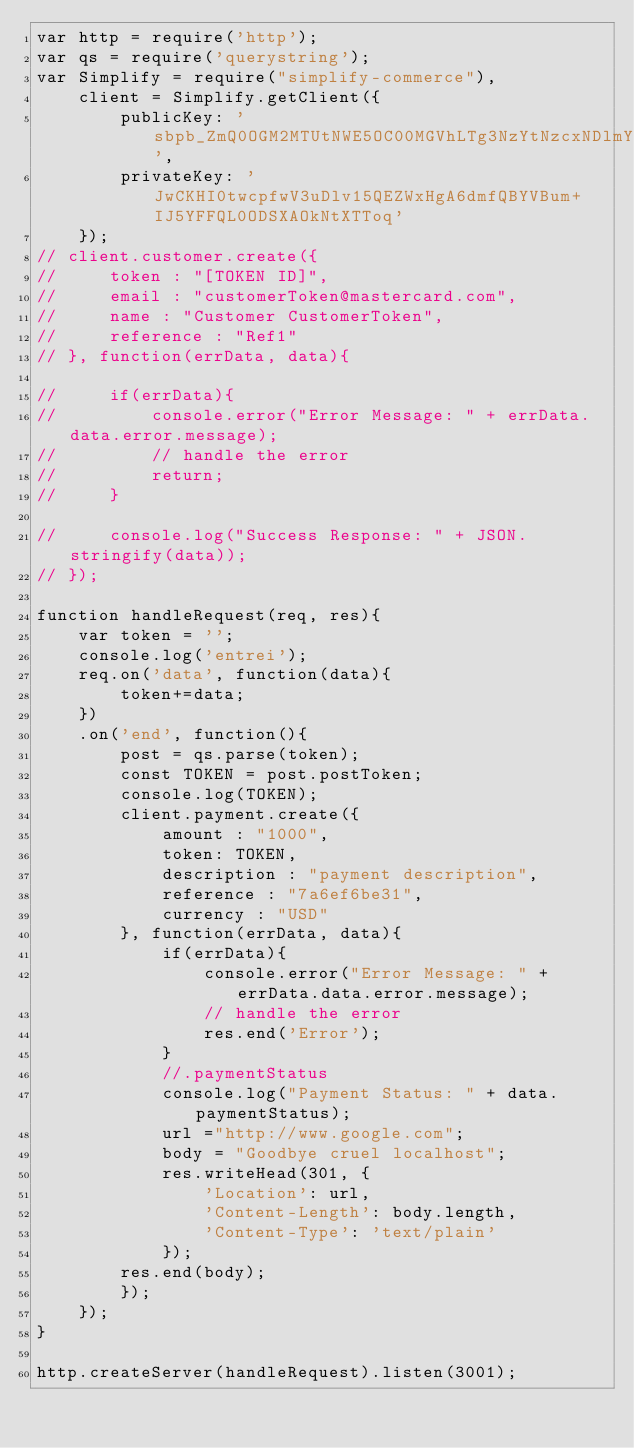<code> <loc_0><loc_0><loc_500><loc_500><_JavaScript_>var http = require('http');
var qs = require('querystring');
var Simplify = require("simplify-commerce"),
    client = Simplify.getClient({
        publicKey: 'sbpb_ZmQ0OGM2MTUtNWE5OC00MGVhLTg3NzYtNzcxNDlmYmUwMTg3',
        privateKey: 'JwCKHI0twcpfwV3uDlv15QEZWxHgA6dmfQBYVBum+IJ5YFFQL0ODSXAOkNtXTToq'
    });
// client.customer.create({
//     token : "[TOKEN ID]",
//     email : "customerToken@mastercard.com",
//     name : "Customer CustomerToken",
//     reference : "Ref1"
// }, function(errData, data){
 
//     if(errData){
//         console.error("Error Message: " + errData.data.error.message);
//         // handle the error
//         return;
//     }
 
//     console.log("Success Response: " + JSON.stringify(data));
// });

function handleRequest(req, res){
    var token = '';
    console.log('entrei');
    req.on('data', function(data){
        token+=data;
    })
    .on('end', function(){
        post = qs.parse(token);
        const TOKEN = post.postToken;
        console.log(TOKEN);
        client.payment.create({
            amount : "1000",
            token: TOKEN,
            description : "payment description",
            reference : "7a6ef6be31",
            currency : "USD"
        }, function(errData, data){ 
            if(errData){
                console.error("Error Message: " + errData.data.error.message);
                // handle the error
                res.end('Error');
            }
            //.paymentStatus
            console.log("Payment Status: " + data.paymentStatus);
            url ="http://www.google.com";
            body = "Goodbye cruel localhost";
            res.writeHead(301, {
                'Location': url,
                'Content-Length': body.length,
                'Content-Type': 'text/plain'
            });
        res.end(body);
        });
    });
}

http.createServer(handleRequest).listen(3001);</code> 